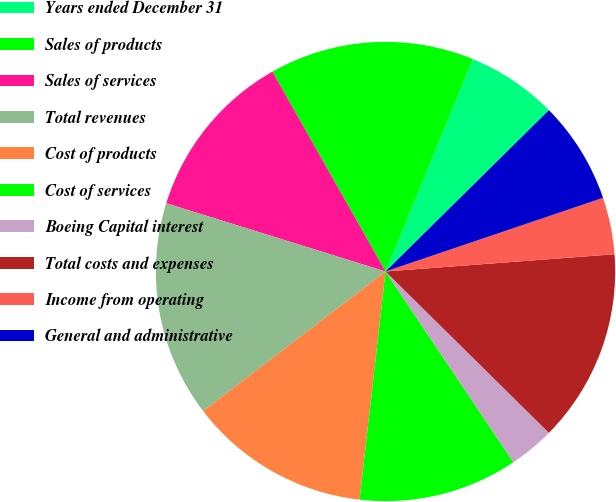Convert chart. <chart><loc_0><loc_0><loc_500><loc_500><pie_chart><fcel>Years ended December 31<fcel>Sales of products<fcel>Sales of services<fcel>Total revenues<fcel>Cost of products<fcel>Cost of services<fcel>Boeing Capital interest<fcel>Total costs and expenses<fcel>Income from operating<fcel>General and administrative<nl><fcel>6.4%<fcel>14.4%<fcel>12.0%<fcel>15.2%<fcel>12.8%<fcel>11.2%<fcel>3.2%<fcel>13.6%<fcel>4.0%<fcel>7.2%<nl></chart> 